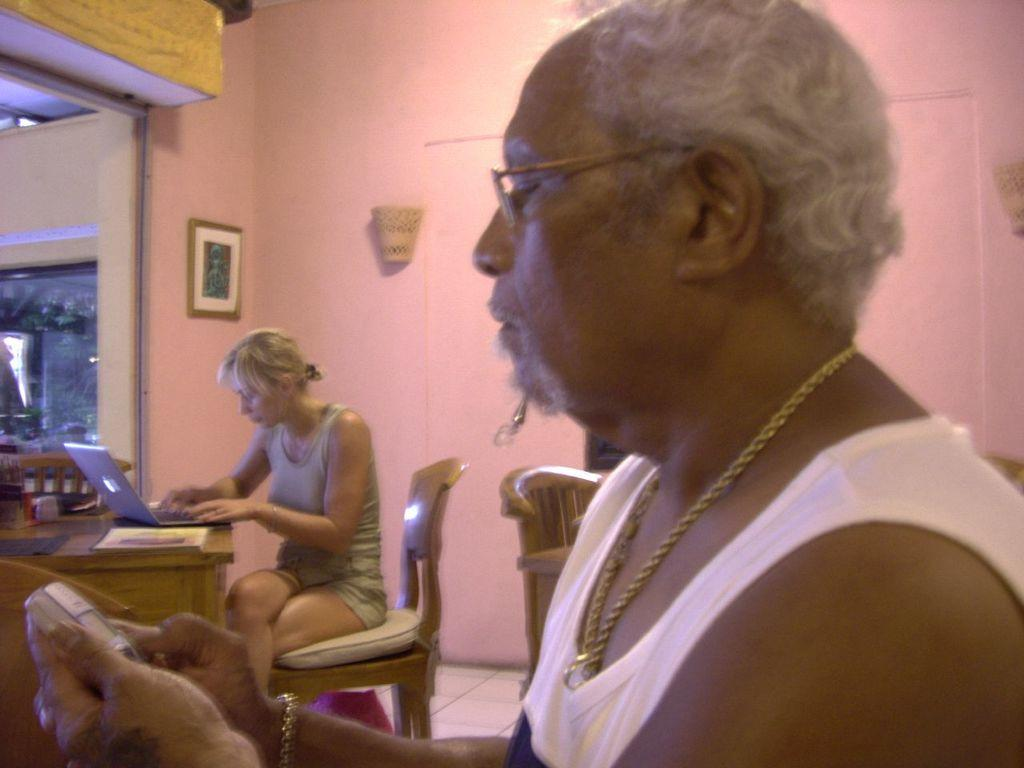What is the man in the image doing? The man is holding a mobile in his hand. What is the woman in the image doing? The woman is seated on a chair and working on a laptop on a table. Can you describe the objects on the wall in the image? There is a photo frame on the wall. What is the woman using to work on the laptop? The woman is using a table to work on the laptop. What type of quiet can be heard in the image? There is no reference to any sound or quiet in the image, so it cannot be determined. 